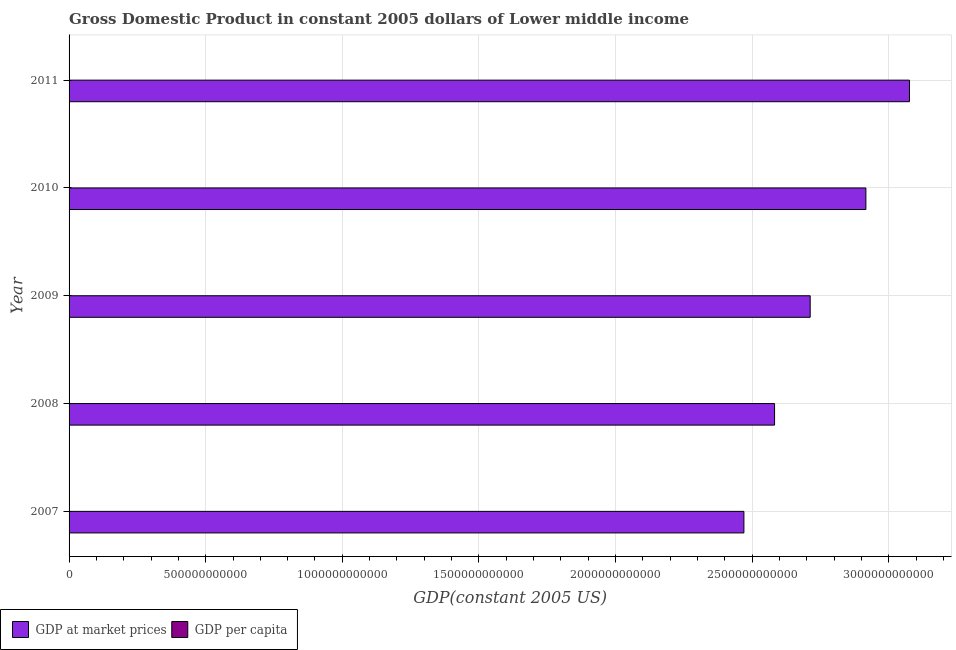How many groups of bars are there?
Your answer should be compact. 5. Are the number of bars per tick equal to the number of legend labels?
Keep it short and to the point. Yes. Are the number of bars on each tick of the Y-axis equal?
Your response must be concise. Yes. How many bars are there on the 5th tick from the top?
Provide a short and direct response. 2. How many bars are there on the 2nd tick from the bottom?
Give a very brief answer. 2. What is the gdp at market prices in 2011?
Provide a short and direct response. 3.08e+12. Across all years, what is the maximum gdp per capita?
Provide a short and direct response. 1117.62. Across all years, what is the minimum gdp per capita?
Offer a very short reply. 954.96. In which year was the gdp at market prices maximum?
Your answer should be very brief. 2011. What is the total gdp per capita in the graph?
Make the answer very short. 5148.04. What is the difference between the gdp at market prices in 2007 and that in 2010?
Provide a succinct answer. -4.46e+11. What is the difference between the gdp per capita in 2008 and the gdp at market prices in 2010?
Your answer should be very brief. -2.92e+12. What is the average gdp at market prices per year?
Your answer should be very brief. 2.75e+12. In the year 2007, what is the difference between the gdp per capita and gdp at market prices?
Ensure brevity in your answer.  -2.47e+12. What is the ratio of the gdp per capita in 2008 to that in 2010?
Offer a very short reply. 0.91. Is the difference between the gdp per capita in 2008 and 2009 greater than the difference between the gdp at market prices in 2008 and 2009?
Your answer should be compact. Yes. What is the difference between the highest and the second highest gdp at market prices?
Offer a terse response. 1.60e+11. What is the difference between the highest and the lowest gdp per capita?
Offer a terse response. 162.66. What does the 1st bar from the top in 2008 represents?
Make the answer very short. GDP per capita. What does the 2nd bar from the bottom in 2010 represents?
Ensure brevity in your answer.  GDP per capita. How many bars are there?
Offer a very short reply. 10. How many years are there in the graph?
Provide a succinct answer. 5. What is the difference between two consecutive major ticks on the X-axis?
Make the answer very short. 5.00e+11. Are the values on the major ticks of X-axis written in scientific E-notation?
Your answer should be very brief. No. What is the title of the graph?
Provide a short and direct response. Gross Domestic Product in constant 2005 dollars of Lower middle income. Does "GDP" appear as one of the legend labels in the graph?
Ensure brevity in your answer.  No. What is the label or title of the X-axis?
Provide a succinct answer. GDP(constant 2005 US). What is the GDP(constant 2005 US) of GDP at market prices in 2007?
Ensure brevity in your answer.  2.47e+12. What is the GDP(constant 2005 US) in GDP per capita in 2007?
Provide a short and direct response. 954.96. What is the GDP(constant 2005 US) of GDP at market prices in 2008?
Provide a succinct answer. 2.58e+12. What is the GDP(constant 2005 US) in GDP per capita in 2008?
Offer a terse response. 982.79. What is the GDP(constant 2005 US) of GDP at market prices in 2009?
Make the answer very short. 2.71e+12. What is the GDP(constant 2005 US) in GDP per capita in 2009?
Your response must be concise. 1016.51. What is the GDP(constant 2005 US) of GDP at market prices in 2010?
Provide a short and direct response. 2.92e+12. What is the GDP(constant 2005 US) in GDP per capita in 2010?
Offer a very short reply. 1076.16. What is the GDP(constant 2005 US) in GDP at market prices in 2011?
Keep it short and to the point. 3.08e+12. What is the GDP(constant 2005 US) in GDP per capita in 2011?
Your answer should be compact. 1117.62. Across all years, what is the maximum GDP(constant 2005 US) in GDP at market prices?
Your answer should be very brief. 3.08e+12. Across all years, what is the maximum GDP(constant 2005 US) of GDP per capita?
Your response must be concise. 1117.62. Across all years, what is the minimum GDP(constant 2005 US) in GDP at market prices?
Offer a terse response. 2.47e+12. Across all years, what is the minimum GDP(constant 2005 US) in GDP per capita?
Offer a very short reply. 954.96. What is the total GDP(constant 2005 US) in GDP at market prices in the graph?
Offer a terse response. 1.38e+13. What is the total GDP(constant 2005 US) of GDP per capita in the graph?
Give a very brief answer. 5148.04. What is the difference between the GDP(constant 2005 US) in GDP at market prices in 2007 and that in 2008?
Offer a very short reply. -1.12e+11. What is the difference between the GDP(constant 2005 US) of GDP per capita in 2007 and that in 2008?
Your answer should be compact. -27.83. What is the difference between the GDP(constant 2005 US) of GDP at market prices in 2007 and that in 2009?
Provide a succinct answer. -2.43e+11. What is the difference between the GDP(constant 2005 US) of GDP per capita in 2007 and that in 2009?
Your response must be concise. -61.56. What is the difference between the GDP(constant 2005 US) of GDP at market prices in 2007 and that in 2010?
Ensure brevity in your answer.  -4.46e+11. What is the difference between the GDP(constant 2005 US) of GDP per capita in 2007 and that in 2010?
Provide a succinct answer. -121.2. What is the difference between the GDP(constant 2005 US) of GDP at market prices in 2007 and that in 2011?
Keep it short and to the point. -6.06e+11. What is the difference between the GDP(constant 2005 US) in GDP per capita in 2007 and that in 2011?
Offer a very short reply. -162.66. What is the difference between the GDP(constant 2005 US) in GDP at market prices in 2008 and that in 2009?
Offer a very short reply. -1.30e+11. What is the difference between the GDP(constant 2005 US) in GDP per capita in 2008 and that in 2009?
Your response must be concise. -33.72. What is the difference between the GDP(constant 2005 US) of GDP at market prices in 2008 and that in 2010?
Provide a succinct answer. -3.34e+11. What is the difference between the GDP(constant 2005 US) in GDP per capita in 2008 and that in 2010?
Provide a short and direct response. -93.37. What is the difference between the GDP(constant 2005 US) of GDP at market prices in 2008 and that in 2011?
Keep it short and to the point. -4.94e+11. What is the difference between the GDP(constant 2005 US) of GDP per capita in 2008 and that in 2011?
Provide a succinct answer. -134.82. What is the difference between the GDP(constant 2005 US) in GDP at market prices in 2009 and that in 2010?
Offer a terse response. -2.04e+11. What is the difference between the GDP(constant 2005 US) in GDP per capita in 2009 and that in 2010?
Provide a succinct answer. -59.64. What is the difference between the GDP(constant 2005 US) of GDP at market prices in 2009 and that in 2011?
Your answer should be compact. -3.63e+11. What is the difference between the GDP(constant 2005 US) of GDP per capita in 2009 and that in 2011?
Your answer should be very brief. -101.1. What is the difference between the GDP(constant 2005 US) of GDP at market prices in 2010 and that in 2011?
Provide a succinct answer. -1.60e+11. What is the difference between the GDP(constant 2005 US) in GDP per capita in 2010 and that in 2011?
Make the answer very short. -41.46. What is the difference between the GDP(constant 2005 US) in GDP at market prices in 2007 and the GDP(constant 2005 US) in GDP per capita in 2008?
Your answer should be very brief. 2.47e+12. What is the difference between the GDP(constant 2005 US) in GDP at market prices in 2007 and the GDP(constant 2005 US) in GDP per capita in 2009?
Give a very brief answer. 2.47e+12. What is the difference between the GDP(constant 2005 US) of GDP at market prices in 2007 and the GDP(constant 2005 US) of GDP per capita in 2010?
Provide a short and direct response. 2.47e+12. What is the difference between the GDP(constant 2005 US) in GDP at market prices in 2007 and the GDP(constant 2005 US) in GDP per capita in 2011?
Give a very brief answer. 2.47e+12. What is the difference between the GDP(constant 2005 US) of GDP at market prices in 2008 and the GDP(constant 2005 US) of GDP per capita in 2009?
Keep it short and to the point. 2.58e+12. What is the difference between the GDP(constant 2005 US) of GDP at market prices in 2008 and the GDP(constant 2005 US) of GDP per capita in 2010?
Give a very brief answer. 2.58e+12. What is the difference between the GDP(constant 2005 US) in GDP at market prices in 2008 and the GDP(constant 2005 US) in GDP per capita in 2011?
Keep it short and to the point. 2.58e+12. What is the difference between the GDP(constant 2005 US) of GDP at market prices in 2009 and the GDP(constant 2005 US) of GDP per capita in 2010?
Your answer should be very brief. 2.71e+12. What is the difference between the GDP(constant 2005 US) in GDP at market prices in 2009 and the GDP(constant 2005 US) in GDP per capita in 2011?
Provide a succinct answer. 2.71e+12. What is the difference between the GDP(constant 2005 US) of GDP at market prices in 2010 and the GDP(constant 2005 US) of GDP per capita in 2011?
Provide a short and direct response. 2.92e+12. What is the average GDP(constant 2005 US) in GDP at market prices per year?
Offer a very short reply. 2.75e+12. What is the average GDP(constant 2005 US) in GDP per capita per year?
Your response must be concise. 1029.61. In the year 2007, what is the difference between the GDP(constant 2005 US) in GDP at market prices and GDP(constant 2005 US) in GDP per capita?
Give a very brief answer. 2.47e+12. In the year 2008, what is the difference between the GDP(constant 2005 US) of GDP at market prices and GDP(constant 2005 US) of GDP per capita?
Give a very brief answer. 2.58e+12. In the year 2009, what is the difference between the GDP(constant 2005 US) of GDP at market prices and GDP(constant 2005 US) of GDP per capita?
Your response must be concise. 2.71e+12. In the year 2010, what is the difference between the GDP(constant 2005 US) in GDP at market prices and GDP(constant 2005 US) in GDP per capita?
Your response must be concise. 2.92e+12. In the year 2011, what is the difference between the GDP(constant 2005 US) in GDP at market prices and GDP(constant 2005 US) in GDP per capita?
Ensure brevity in your answer.  3.08e+12. What is the ratio of the GDP(constant 2005 US) in GDP at market prices in 2007 to that in 2008?
Offer a terse response. 0.96. What is the ratio of the GDP(constant 2005 US) of GDP per capita in 2007 to that in 2008?
Give a very brief answer. 0.97. What is the ratio of the GDP(constant 2005 US) of GDP at market prices in 2007 to that in 2009?
Your answer should be compact. 0.91. What is the ratio of the GDP(constant 2005 US) of GDP per capita in 2007 to that in 2009?
Your answer should be compact. 0.94. What is the ratio of the GDP(constant 2005 US) in GDP at market prices in 2007 to that in 2010?
Offer a terse response. 0.85. What is the ratio of the GDP(constant 2005 US) of GDP per capita in 2007 to that in 2010?
Keep it short and to the point. 0.89. What is the ratio of the GDP(constant 2005 US) in GDP at market prices in 2007 to that in 2011?
Ensure brevity in your answer.  0.8. What is the ratio of the GDP(constant 2005 US) of GDP per capita in 2007 to that in 2011?
Provide a short and direct response. 0.85. What is the ratio of the GDP(constant 2005 US) in GDP at market prices in 2008 to that in 2009?
Give a very brief answer. 0.95. What is the ratio of the GDP(constant 2005 US) in GDP per capita in 2008 to that in 2009?
Your answer should be very brief. 0.97. What is the ratio of the GDP(constant 2005 US) in GDP at market prices in 2008 to that in 2010?
Your answer should be very brief. 0.89. What is the ratio of the GDP(constant 2005 US) of GDP per capita in 2008 to that in 2010?
Give a very brief answer. 0.91. What is the ratio of the GDP(constant 2005 US) in GDP at market prices in 2008 to that in 2011?
Provide a short and direct response. 0.84. What is the ratio of the GDP(constant 2005 US) of GDP per capita in 2008 to that in 2011?
Keep it short and to the point. 0.88. What is the ratio of the GDP(constant 2005 US) of GDP at market prices in 2009 to that in 2010?
Provide a succinct answer. 0.93. What is the ratio of the GDP(constant 2005 US) in GDP per capita in 2009 to that in 2010?
Make the answer very short. 0.94. What is the ratio of the GDP(constant 2005 US) in GDP at market prices in 2009 to that in 2011?
Provide a short and direct response. 0.88. What is the ratio of the GDP(constant 2005 US) in GDP per capita in 2009 to that in 2011?
Your response must be concise. 0.91. What is the ratio of the GDP(constant 2005 US) of GDP at market prices in 2010 to that in 2011?
Offer a very short reply. 0.95. What is the ratio of the GDP(constant 2005 US) in GDP per capita in 2010 to that in 2011?
Provide a succinct answer. 0.96. What is the difference between the highest and the second highest GDP(constant 2005 US) in GDP at market prices?
Make the answer very short. 1.60e+11. What is the difference between the highest and the second highest GDP(constant 2005 US) of GDP per capita?
Provide a succinct answer. 41.46. What is the difference between the highest and the lowest GDP(constant 2005 US) in GDP at market prices?
Your answer should be very brief. 6.06e+11. What is the difference between the highest and the lowest GDP(constant 2005 US) of GDP per capita?
Provide a succinct answer. 162.66. 